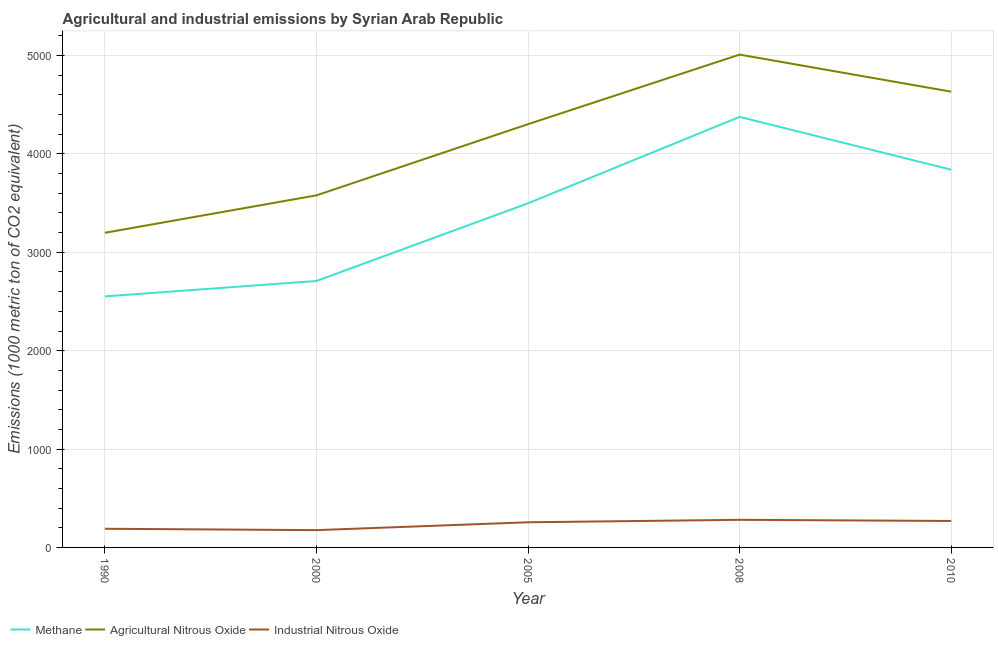How many different coloured lines are there?
Give a very brief answer. 3. Does the line corresponding to amount of methane emissions intersect with the line corresponding to amount of industrial nitrous oxide emissions?
Provide a short and direct response. No. What is the amount of methane emissions in 2000?
Offer a terse response. 2708.8. Across all years, what is the maximum amount of industrial nitrous oxide emissions?
Your answer should be compact. 280.7. Across all years, what is the minimum amount of industrial nitrous oxide emissions?
Your response must be concise. 175.8. In which year was the amount of methane emissions maximum?
Make the answer very short. 2008. What is the total amount of agricultural nitrous oxide emissions in the graph?
Your answer should be compact. 2.07e+04. What is the difference between the amount of agricultural nitrous oxide emissions in 1990 and that in 2000?
Make the answer very short. -380.6. What is the difference between the amount of agricultural nitrous oxide emissions in 2008 and the amount of methane emissions in 2000?
Offer a very short reply. 2301.1. What is the average amount of agricultural nitrous oxide emissions per year?
Make the answer very short. 4144.66. In the year 2000, what is the difference between the amount of methane emissions and amount of industrial nitrous oxide emissions?
Offer a very short reply. 2533. What is the ratio of the amount of methane emissions in 2000 to that in 2010?
Your answer should be compact. 0.71. What is the difference between the highest and the second highest amount of methane emissions?
Make the answer very short. 537. What is the difference between the highest and the lowest amount of methane emissions?
Offer a very short reply. 1825.1. Is the sum of the amount of methane emissions in 2008 and 2010 greater than the maximum amount of agricultural nitrous oxide emissions across all years?
Provide a short and direct response. Yes. Is it the case that in every year, the sum of the amount of methane emissions and amount of agricultural nitrous oxide emissions is greater than the amount of industrial nitrous oxide emissions?
Give a very brief answer. Yes. Is the amount of agricultural nitrous oxide emissions strictly less than the amount of industrial nitrous oxide emissions over the years?
Offer a terse response. No. How many lines are there?
Your answer should be compact. 3. How many legend labels are there?
Ensure brevity in your answer.  3. What is the title of the graph?
Provide a succinct answer. Agricultural and industrial emissions by Syrian Arab Republic. Does "Profit Tax" appear as one of the legend labels in the graph?
Provide a short and direct response. No. What is the label or title of the X-axis?
Ensure brevity in your answer.  Year. What is the label or title of the Y-axis?
Give a very brief answer. Emissions (1000 metric ton of CO2 equivalent). What is the Emissions (1000 metric ton of CO2 equivalent) in Methane in 1990?
Offer a very short reply. 2551.7. What is the Emissions (1000 metric ton of CO2 equivalent) of Agricultural Nitrous Oxide in 1990?
Your response must be concise. 3198.5. What is the Emissions (1000 metric ton of CO2 equivalent) of Industrial Nitrous Oxide in 1990?
Give a very brief answer. 189.7. What is the Emissions (1000 metric ton of CO2 equivalent) of Methane in 2000?
Ensure brevity in your answer.  2708.8. What is the Emissions (1000 metric ton of CO2 equivalent) in Agricultural Nitrous Oxide in 2000?
Make the answer very short. 3579.1. What is the Emissions (1000 metric ton of CO2 equivalent) of Industrial Nitrous Oxide in 2000?
Keep it short and to the point. 175.8. What is the Emissions (1000 metric ton of CO2 equivalent) of Methane in 2005?
Provide a short and direct response. 3498.3. What is the Emissions (1000 metric ton of CO2 equivalent) of Agricultural Nitrous Oxide in 2005?
Give a very brief answer. 4302.7. What is the Emissions (1000 metric ton of CO2 equivalent) of Industrial Nitrous Oxide in 2005?
Your answer should be compact. 255.6. What is the Emissions (1000 metric ton of CO2 equivalent) in Methane in 2008?
Provide a succinct answer. 4376.8. What is the Emissions (1000 metric ton of CO2 equivalent) of Agricultural Nitrous Oxide in 2008?
Your answer should be compact. 5009.9. What is the Emissions (1000 metric ton of CO2 equivalent) in Industrial Nitrous Oxide in 2008?
Your response must be concise. 280.7. What is the Emissions (1000 metric ton of CO2 equivalent) of Methane in 2010?
Provide a succinct answer. 3839.8. What is the Emissions (1000 metric ton of CO2 equivalent) of Agricultural Nitrous Oxide in 2010?
Give a very brief answer. 4633.1. What is the Emissions (1000 metric ton of CO2 equivalent) in Industrial Nitrous Oxide in 2010?
Provide a succinct answer. 269. Across all years, what is the maximum Emissions (1000 metric ton of CO2 equivalent) of Methane?
Your answer should be compact. 4376.8. Across all years, what is the maximum Emissions (1000 metric ton of CO2 equivalent) of Agricultural Nitrous Oxide?
Offer a very short reply. 5009.9. Across all years, what is the maximum Emissions (1000 metric ton of CO2 equivalent) in Industrial Nitrous Oxide?
Offer a very short reply. 280.7. Across all years, what is the minimum Emissions (1000 metric ton of CO2 equivalent) of Methane?
Give a very brief answer. 2551.7. Across all years, what is the minimum Emissions (1000 metric ton of CO2 equivalent) in Agricultural Nitrous Oxide?
Your response must be concise. 3198.5. Across all years, what is the minimum Emissions (1000 metric ton of CO2 equivalent) in Industrial Nitrous Oxide?
Provide a short and direct response. 175.8. What is the total Emissions (1000 metric ton of CO2 equivalent) of Methane in the graph?
Provide a short and direct response. 1.70e+04. What is the total Emissions (1000 metric ton of CO2 equivalent) in Agricultural Nitrous Oxide in the graph?
Give a very brief answer. 2.07e+04. What is the total Emissions (1000 metric ton of CO2 equivalent) in Industrial Nitrous Oxide in the graph?
Ensure brevity in your answer.  1170.8. What is the difference between the Emissions (1000 metric ton of CO2 equivalent) in Methane in 1990 and that in 2000?
Offer a very short reply. -157.1. What is the difference between the Emissions (1000 metric ton of CO2 equivalent) in Agricultural Nitrous Oxide in 1990 and that in 2000?
Ensure brevity in your answer.  -380.6. What is the difference between the Emissions (1000 metric ton of CO2 equivalent) in Industrial Nitrous Oxide in 1990 and that in 2000?
Provide a succinct answer. 13.9. What is the difference between the Emissions (1000 metric ton of CO2 equivalent) of Methane in 1990 and that in 2005?
Make the answer very short. -946.6. What is the difference between the Emissions (1000 metric ton of CO2 equivalent) of Agricultural Nitrous Oxide in 1990 and that in 2005?
Make the answer very short. -1104.2. What is the difference between the Emissions (1000 metric ton of CO2 equivalent) in Industrial Nitrous Oxide in 1990 and that in 2005?
Your answer should be very brief. -65.9. What is the difference between the Emissions (1000 metric ton of CO2 equivalent) of Methane in 1990 and that in 2008?
Provide a short and direct response. -1825.1. What is the difference between the Emissions (1000 metric ton of CO2 equivalent) of Agricultural Nitrous Oxide in 1990 and that in 2008?
Keep it short and to the point. -1811.4. What is the difference between the Emissions (1000 metric ton of CO2 equivalent) in Industrial Nitrous Oxide in 1990 and that in 2008?
Your answer should be compact. -91. What is the difference between the Emissions (1000 metric ton of CO2 equivalent) of Methane in 1990 and that in 2010?
Ensure brevity in your answer.  -1288.1. What is the difference between the Emissions (1000 metric ton of CO2 equivalent) of Agricultural Nitrous Oxide in 1990 and that in 2010?
Make the answer very short. -1434.6. What is the difference between the Emissions (1000 metric ton of CO2 equivalent) in Industrial Nitrous Oxide in 1990 and that in 2010?
Provide a succinct answer. -79.3. What is the difference between the Emissions (1000 metric ton of CO2 equivalent) in Methane in 2000 and that in 2005?
Your response must be concise. -789.5. What is the difference between the Emissions (1000 metric ton of CO2 equivalent) of Agricultural Nitrous Oxide in 2000 and that in 2005?
Keep it short and to the point. -723.6. What is the difference between the Emissions (1000 metric ton of CO2 equivalent) in Industrial Nitrous Oxide in 2000 and that in 2005?
Make the answer very short. -79.8. What is the difference between the Emissions (1000 metric ton of CO2 equivalent) in Methane in 2000 and that in 2008?
Provide a succinct answer. -1668. What is the difference between the Emissions (1000 metric ton of CO2 equivalent) of Agricultural Nitrous Oxide in 2000 and that in 2008?
Ensure brevity in your answer.  -1430.8. What is the difference between the Emissions (1000 metric ton of CO2 equivalent) in Industrial Nitrous Oxide in 2000 and that in 2008?
Your response must be concise. -104.9. What is the difference between the Emissions (1000 metric ton of CO2 equivalent) in Methane in 2000 and that in 2010?
Your answer should be very brief. -1131. What is the difference between the Emissions (1000 metric ton of CO2 equivalent) of Agricultural Nitrous Oxide in 2000 and that in 2010?
Ensure brevity in your answer.  -1054. What is the difference between the Emissions (1000 metric ton of CO2 equivalent) of Industrial Nitrous Oxide in 2000 and that in 2010?
Your answer should be very brief. -93.2. What is the difference between the Emissions (1000 metric ton of CO2 equivalent) of Methane in 2005 and that in 2008?
Make the answer very short. -878.5. What is the difference between the Emissions (1000 metric ton of CO2 equivalent) in Agricultural Nitrous Oxide in 2005 and that in 2008?
Give a very brief answer. -707.2. What is the difference between the Emissions (1000 metric ton of CO2 equivalent) of Industrial Nitrous Oxide in 2005 and that in 2008?
Offer a very short reply. -25.1. What is the difference between the Emissions (1000 metric ton of CO2 equivalent) of Methane in 2005 and that in 2010?
Make the answer very short. -341.5. What is the difference between the Emissions (1000 metric ton of CO2 equivalent) of Agricultural Nitrous Oxide in 2005 and that in 2010?
Ensure brevity in your answer.  -330.4. What is the difference between the Emissions (1000 metric ton of CO2 equivalent) of Methane in 2008 and that in 2010?
Your answer should be very brief. 537. What is the difference between the Emissions (1000 metric ton of CO2 equivalent) of Agricultural Nitrous Oxide in 2008 and that in 2010?
Provide a succinct answer. 376.8. What is the difference between the Emissions (1000 metric ton of CO2 equivalent) in Industrial Nitrous Oxide in 2008 and that in 2010?
Provide a short and direct response. 11.7. What is the difference between the Emissions (1000 metric ton of CO2 equivalent) in Methane in 1990 and the Emissions (1000 metric ton of CO2 equivalent) in Agricultural Nitrous Oxide in 2000?
Make the answer very short. -1027.4. What is the difference between the Emissions (1000 metric ton of CO2 equivalent) in Methane in 1990 and the Emissions (1000 metric ton of CO2 equivalent) in Industrial Nitrous Oxide in 2000?
Provide a short and direct response. 2375.9. What is the difference between the Emissions (1000 metric ton of CO2 equivalent) in Agricultural Nitrous Oxide in 1990 and the Emissions (1000 metric ton of CO2 equivalent) in Industrial Nitrous Oxide in 2000?
Provide a short and direct response. 3022.7. What is the difference between the Emissions (1000 metric ton of CO2 equivalent) of Methane in 1990 and the Emissions (1000 metric ton of CO2 equivalent) of Agricultural Nitrous Oxide in 2005?
Your response must be concise. -1751. What is the difference between the Emissions (1000 metric ton of CO2 equivalent) of Methane in 1990 and the Emissions (1000 metric ton of CO2 equivalent) of Industrial Nitrous Oxide in 2005?
Offer a very short reply. 2296.1. What is the difference between the Emissions (1000 metric ton of CO2 equivalent) of Agricultural Nitrous Oxide in 1990 and the Emissions (1000 metric ton of CO2 equivalent) of Industrial Nitrous Oxide in 2005?
Make the answer very short. 2942.9. What is the difference between the Emissions (1000 metric ton of CO2 equivalent) of Methane in 1990 and the Emissions (1000 metric ton of CO2 equivalent) of Agricultural Nitrous Oxide in 2008?
Give a very brief answer. -2458.2. What is the difference between the Emissions (1000 metric ton of CO2 equivalent) of Methane in 1990 and the Emissions (1000 metric ton of CO2 equivalent) of Industrial Nitrous Oxide in 2008?
Offer a very short reply. 2271. What is the difference between the Emissions (1000 metric ton of CO2 equivalent) in Agricultural Nitrous Oxide in 1990 and the Emissions (1000 metric ton of CO2 equivalent) in Industrial Nitrous Oxide in 2008?
Make the answer very short. 2917.8. What is the difference between the Emissions (1000 metric ton of CO2 equivalent) of Methane in 1990 and the Emissions (1000 metric ton of CO2 equivalent) of Agricultural Nitrous Oxide in 2010?
Give a very brief answer. -2081.4. What is the difference between the Emissions (1000 metric ton of CO2 equivalent) of Methane in 1990 and the Emissions (1000 metric ton of CO2 equivalent) of Industrial Nitrous Oxide in 2010?
Offer a terse response. 2282.7. What is the difference between the Emissions (1000 metric ton of CO2 equivalent) of Agricultural Nitrous Oxide in 1990 and the Emissions (1000 metric ton of CO2 equivalent) of Industrial Nitrous Oxide in 2010?
Your answer should be very brief. 2929.5. What is the difference between the Emissions (1000 metric ton of CO2 equivalent) in Methane in 2000 and the Emissions (1000 metric ton of CO2 equivalent) in Agricultural Nitrous Oxide in 2005?
Offer a terse response. -1593.9. What is the difference between the Emissions (1000 metric ton of CO2 equivalent) of Methane in 2000 and the Emissions (1000 metric ton of CO2 equivalent) of Industrial Nitrous Oxide in 2005?
Your response must be concise. 2453.2. What is the difference between the Emissions (1000 metric ton of CO2 equivalent) in Agricultural Nitrous Oxide in 2000 and the Emissions (1000 metric ton of CO2 equivalent) in Industrial Nitrous Oxide in 2005?
Keep it short and to the point. 3323.5. What is the difference between the Emissions (1000 metric ton of CO2 equivalent) in Methane in 2000 and the Emissions (1000 metric ton of CO2 equivalent) in Agricultural Nitrous Oxide in 2008?
Keep it short and to the point. -2301.1. What is the difference between the Emissions (1000 metric ton of CO2 equivalent) in Methane in 2000 and the Emissions (1000 metric ton of CO2 equivalent) in Industrial Nitrous Oxide in 2008?
Give a very brief answer. 2428.1. What is the difference between the Emissions (1000 metric ton of CO2 equivalent) of Agricultural Nitrous Oxide in 2000 and the Emissions (1000 metric ton of CO2 equivalent) of Industrial Nitrous Oxide in 2008?
Your response must be concise. 3298.4. What is the difference between the Emissions (1000 metric ton of CO2 equivalent) of Methane in 2000 and the Emissions (1000 metric ton of CO2 equivalent) of Agricultural Nitrous Oxide in 2010?
Your response must be concise. -1924.3. What is the difference between the Emissions (1000 metric ton of CO2 equivalent) of Methane in 2000 and the Emissions (1000 metric ton of CO2 equivalent) of Industrial Nitrous Oxide in 2010?
Your answer should be very brief. 2439.8. What is the difference between the Emissions (1000 metric ton of CO2 equivalent) in Agricultural Nitrous Oxide in 2000 and the Emissions (1000 metric ton of CO2 equivalent) in Industrial Nitrous Oxide in 2010?
Provide a succinct answer. 3310.1. What is the difference between the Emissions (1000 metric ton of CO2 equivalent) in Methane in 2005 and the Emissions (1000 metric ton of CO2 equivalent) in Agricultural Nitrous Oxide in 2008?
Offer a terse response. -1511.6. What is the difference between the Emissions (1000 metric ton of CO2 equivalent) of Methane in 2005 and the Emissions (1000 metric ton of CO2 equivalent) of Industrial Nitrous Oxide in 2008?
Offer a terse response. 3217.6. What is the difference between the Emissions (1000 metric ton of CO2 equivalent) in Agricultural Nitrous Oxide in 2005 and the Emissions (1000 metric ton of CO2 equivalent) in Industrial Nitrous Oxide in 2008?
Provide a short and direct response. 4022. What is the difference between the Emissions (1000 metric ton of CO2 equivalent) of Methane in 2005 and the Emissions (1000 metric ton of CO2 equivalent) of Agricultural Nitrous Oxide in 2010?
Offer a very short reply. -1134.8. What is the difference between the Emissions (1000 metric ton of CO2 equivalent) in Methane in 2005 and the Emissions (1000 metric ton of CO2 equivalent) in Industrial Nitrous Oxide in 2010?
Give a very brief answer. 3229.3. What is the difference between the Emissions (1000 metric ton of CO2 equivalent) in Agricultural Nitrous Oxide in 2005 and the Emissions (1000 metric ton of CO2 equivalent) in Industrial Nitrous Oxide in 2010?
Make the answer very short. 4033.7. What is the difference between the Emissions (1000 metric ton of CO2 equivalent) of Methane in 2008 and the Emissions (1000 metric ton of CO2 equivalent) of Agricultural Nitrous Oxide in 2010?
Keep it short and to the point. -256.3. What is the difference between the Emissions (1000 metric ton of CO2 equivalent) in Methane in 2008 and the Emissions (1000 metric ton of CO2 equivalent) in Industrial Nitrous Oxide in 2010?
Ensure brevity in your answer.  4107.8. What is the difference between the Emissions (1000 metric ton of CO2 equivalent) in Agricultural Nitrous Oxide in 2008 and the Emissions (1000 metric ton of CO2 equivalent) in Industrial Nitrous Oxide in 2010?
Offer a very short reply. 4740.9. What is the average Emissions (1000 metric ton of CO2 equivalent) of Methane per year?
Provide a short and direct response. 3395.08. What is the average Emissions (1000 metric ton of CO2 equivalent) of Agricultural Nitrous Oxide per year?
Offer a terse response. 4144.66. What is the average Emissions (1000 metric ton of CO2 equivalent) in Industrial Nitrous Oxide per year?
Your answer should be compact. 234.16. In the year 1990, what is the difference between the Emissions (1000 metric ton of CO2 equivalent) in Methane and Emissions (1000 metric ton of CO2 equivalent) in Agricultural Nitrous Oxide?
Keep it short and to the point. -646.8. In the year 1990, what is the difference between the Emissions (1000 metric ton of CO2 equivalent) in Methane and Emissions (1000 metric ton of CO2 equivalent) in Industrial Nitrous Oxide?
Your response must be concise. 2362. In the year 1990, what is the difference between the Emissions (1000 metric ton of CO2 equivalent) of Agricultural Nitrous Oxide and Emissions (1000 metric ton of CO2 equivalent) of Industrial Nitrous Oxide?
Provide a short and direct response. 3008.8. In the year 2000, what is the difference between the Emissions (1000 metric ton of CO2 equivalent) in Methane and Emissions (1000 metric ton of CO2 equivalent) in Agricultural Nitrous Oxide?
Your answer should be compact. -870.3. In the year 2000, what is the difference between the Emissions (1000 metric ton of CO2 equivalent) in Methane and Emissions (1000 metric ton of CO2 equivalent) in Industrial Nitrous Oxide?
Provide a succinct answer. 2533. In the year 2000, what is the difference between the Emissions (1000 metric ton of CO2 equivalent) in Agricultural Nitrous Oxide and Emissions (1000 metric ton of CO2 equivalent) in Industrial Nitrous Oxide?
Ensure brevity in your answer.  3403.3. In the year 2005, what is the difference between the Emissions (1000 metric ton of CO2 equivalent) of Methane and Emissions (1000 metric ton of CO2 equivalent) of Agricultural Nitrous Oxide?
Make the answer very short. -804.4. In the year 2005, what is the difference between the Emissions (1000 metric ton of CO2 equivalent) of Methane and Emissions (1000 metric ton of CO2 equivalent) of Industrial Nitrous Oxide?
Provide a succinct answer. 3242.7. In the year 2005, what is the difference between the Emissions (1000 metric ton of CO2 equivalent) of Agricultural Nitrous Oxide and Emissions (1000 metric ton of CO2 equivalent) of Industrial Nitrous Oxide?
Provide a succinct answer. 4047.1. In the year 2008, what is the difference between the Emissions (1000 metric ton of CO2 equivalent) in Methane and Emissions (1000 metric ton of CO2 equivalent) in Agricultural Nitrous Oxide?
Provide a succinct answer. -633.1. In the year 2008, what is the difference between the Emissions (1000 metric ton of CO2 equivalent) in Methane and Emissions (1000 metric ton of CO2 equivalent) in Industrial Nitrous Oxide?
Make the answer very short. 4096.1. In the year 2008, what is the difference between the Emissions (1000 metric ton of CO2 equivalent) in Agricultural Nitrous Oxide and Emissions (1000 metric ton of CO2 equivalent) in Industrial Nitrous Oxide?
Ensure brevity in your answer.  4729.2. In the year 2010, what is the difference between the Emissions (1000 metric ton of CO2 equivalent) in Methane and Emissions (1000 metric ton of CO2 equivalent) in Agricultural Nitrous Oxide?
Offer a terse response. -793.3. In the year 2010, what is the difference between the Emissions (1000 metric ton of CO2 equivalent) in Methane and Emissions (1000 metric ton of CO2 equivalent) in Industrial Nitrous Oxide?
Your answer should be compact. 3570.8. In the year 2010, what is the difference between the Emissions (1000 metric ton of CO2 equivalent) in Agricultural Nitrous Oxide and Emissions (1000 metric ton of CO2 equivalent) in Industrial Nitrous Oxide?
Your answer should be compact. 4364.1. What is the ratio of the Emissions (1000 metric ton of CO2 equivalent) of Methane in 1990 to that in 2000?
Offer a terse response. 0.94. What is the ratio of the Emissions (1000 metric ton of CO2 equivalent) of Agricultural Nitrous Oxide in 1990 to that in 2000?
Offer a terse response. 0.89. What is the ratio of the Emissions (1000 metric ton of CO2 equivalent) in Industrial Nitrous Oxide in 1990 to that in 2000?
Give a very brief answer. 1.08. What is the ratio of the Emissions (1000 metric ton of CO2 equivalent) of Methane in 1990 to that in 2005?
Provide a succinct answer. 0.73. What is the ratio of the Emissions (1000 metric ton of CO2 equivalent) of Agricultural Nitrous Oxide in 1990 to that in 2005?
Provide a short and direct response. 0.74. What is the ratio of the Emissions (1000 metric ton of CO2 equivalent) of Industrial Nitrous Oxide in 1990 to that in 2005?
Keep it short and to the point. 0.74. What is the ratio of the Emissions (1000 metric ton of CO2 equivalent) in Methane in 1990 to that in 2008?
Your answer should be compact. 0.58. What is the ratio of the Emissions (1000 metric ton of CO2 equivalent) of Agricultural Nitrous Oxide in 1990 to that in 2008?
Make the answer very short. 0.64. What is the ratio of the Emissions (1000 metric ton of CO2 equivalent) of Industrial Nitrous Oxide in 1990 to that in 2008?
Make the answer very short. 0.68. What is the ratio of the Emissions (1000 metric ton of CO2 equivalent) of Methane in 1990 to that in 2010?
Give a very brief answer. 0.66. What is the ratio of the Emissions (1000 metric ton of CO2 equivalent) in Agricultural Nitrous Oxide in 1990 to that in 2010?
Provide a short and direct response. 0.69. What is the ratio of the Emissions (1000 metric ton of CO2 equivalent) in Industrial Nitrous Oxide in 1990 to that in 2010?
Offer a terse response. 0.71. What is the ratio of the Emissions (1000 metric ton of CO2 equivalent) of Methane in 2000 to that in 2005?
Offer a very short reply. 0.77. What is the ratio of the Emissions (1000 metric ton of CO2 equivalent) in Agricultural Nitrous Oxide in 2000 to that in 2005?
Make the answer very short. 0.83. What is the ratio of the Emissions (1000 metric ton of CO2 equivalent) in Industrial Nitrous Oxide in 2000 to that in 2005?
Provide a succinct answer. 0.69. What is the ratio of the Emissions (1000 metric ton of CO2 equivalent) in Methane in 2000 to that in 2008?
Your answer should be compact. 0.62. What is the ratio of the Emissions (1000 metric ton of CO2 equivalent) in Agricultural Nitrous Oxide in 2000 to that in 2008?
Your answer should be compact. 0.71. What is the ratio of the Emissions (1000 metric ton of CO2 equivalent) of Industrial Nitrous Oxide in 2000 to that in 2008?
Make the answer very short. 0.63. What is the ratio of the Emissions (1000 metric ton of CO2 equivalent) in Methane in 2000 to that in 2010?
Ensure brevity in your answer.  0.71. What is the ratio of the Emissions (1000 metric ton of CO2 equivalent) in Agricultural Nitrous Oxide in 2000 to that in 2010?
Provide a short and direct response. 0.77. What is the ratio of the Emissions (1000 metric ton of CO2 equivalent) in Industrial Nitrous Oxide in 2000 to that in 2010?
Ensure brevity in your answer.  0.65. What is the ratio of the Emissions (1000 metric ton of CO2 equivalent) of Methane in 2005 to that in 2008?
Provide a succinct answer. 0.8. What is the ratio of the Emissions (1000 metric ton of CO2 equivalent) of Agricultural Nitrous Oxide in 2005 to that in 2008?
Make the answer very short. 0.86. What is the ratio of the Emissions (1000 metric ton of CO2 equivalent) in Industrial Nitrous Oxide in 2005 to that in 2008?
Offer a terse response. 0.91. What is the ratio of the Emissions (1000 metric ton of CO2 equivalent) of Methane in 2005 to that in 2010?
Provide a short and direct response. 0.91. What is the ratio of the Emissions (1000 metric ton of CO2 equivalent) of Agricultural Nitrous Oxide in 2005 to that in 2010?
Your answer should be very brief. 0.93. What is the ratio of the Emissions (1000 metric ton of CO2 equivalent) in Industrial Nitrous Oxide in 2005 to that in 2010?
Your response must be concise. 0.95. What is the ratio of the Emissions (1000 metric ton of CO2 equivalent) of Methane in 2008 to that in 2010?
Your response must be concise. 1.14. What is the ratio of the Emissions (1000 metric ton of CO2 equivalent) of Agricultural Nitrous Oxide in 2008 to that in 2010?
Provide a succinct answer. 1.08. What is the ratio of the Emissions (1000 metric ton of CO2 equivalent) of Industrial Nitrous Oxide in 2008 to that in 2010?
Your answer should be very brief. 1.04. What is the difference between the highest and the second highest Emissions (1000 metric ton of CO2 equivalent) of Methane?
Your answer should be compact. 537. What is the difference between the highest and the second highest Emissions (1000 metric ton of CO2 equivalent) in Agricultural Nitrous Oxide?
Give a very brief answer. 376.8. What is the difference between the highest and the second highest Emissions (1000 metric ton of CO2 equivalent) of Industrial Nitrous Oxide?
Give a very brief answer. 11.7. What is the difference between the highest and the lowest Emissions (1000 metric ton of CO2 equivalent) of Methane?
Your answer should be compact. 1825.1. What is the difference between the highest and the lowest Emissions (1000 metric ton of CO2 equivalent) of Agricultural Nitrous Oxide?
Your response must be concise. 1811.4. What is the difference between the highest and the lowest Emissions (1000 metric ton of CO2 equivalent) of Industrial Nitrous Oxide?
Give a very brief answer. 104.9. 